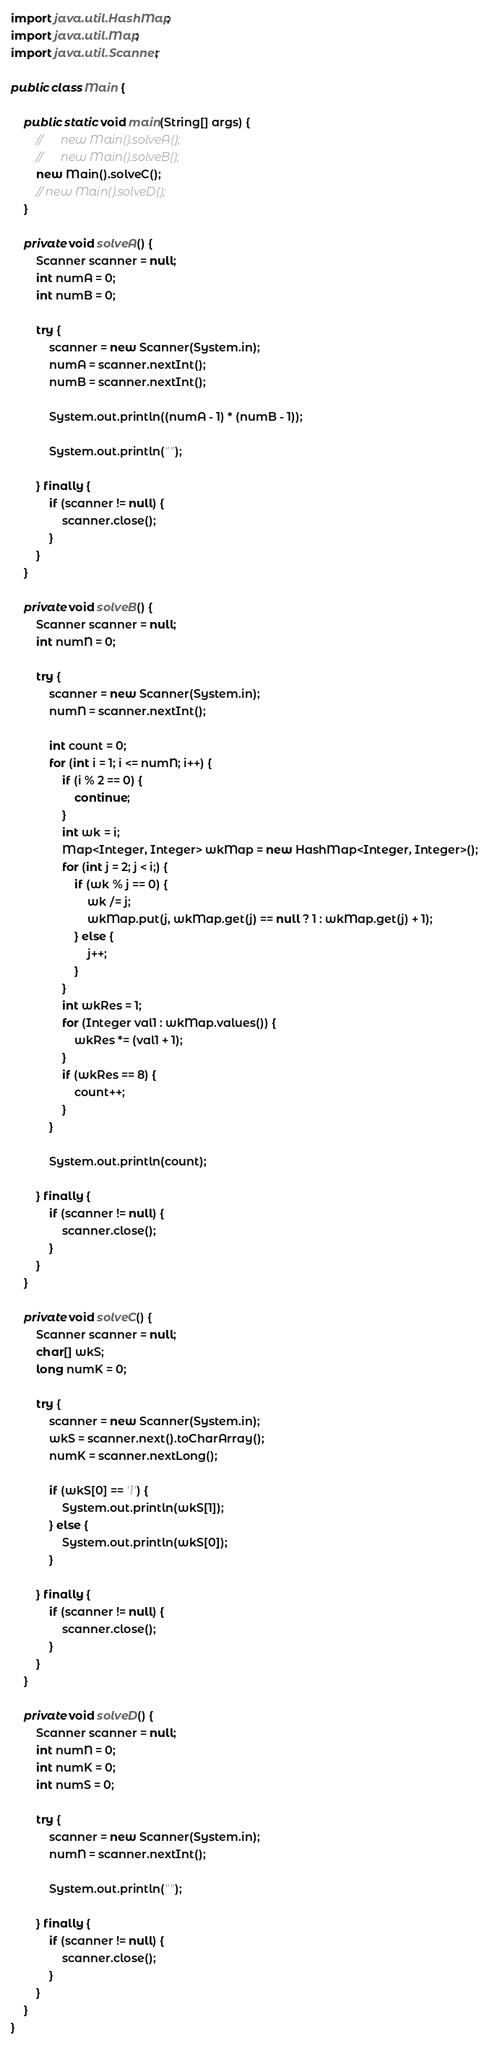Convert code to text. <code><loc_0><loc_0><loc_500><loc_500><_Java_>
import java.util.HashMap;
import java.util.Map;
import java.util.Scanner;

public class Main {

	public static void main(String[] args) {
		//		new Main().solveA();
		//		new Main().solveB();
		new Main().solveC();
		// new Main().solveD();
	}

	private void solveA() {
		Scanner scanner = null;
		int numA = 0;
		int numB = 0;

		try {
			scanner = new Scanner(System.in);
			numA = scanner.nextInt();
			numB = scanner.nextInt();

			System.out.println((numA - 1) * (numB - 1));

			System.out.println("");

		} finally {
			if (scanner != null) {
				scanner.close();
			}
		}
	}

	private void solveB() {
		Scanner scanner = null;
		int numN = 0;

		try {
			scanner = new Scanner(System.in);
			numN = scanner.nextInt();

			int count = 0;
			for (int i = 1; i <= numN; i++) {
				if (i % 2 == 0) {
					continue;
				}
				int wk = i;
				Map<Integer, Integer> wkMap = new HashMap<Integer, Integer>();
				for (int j = 2; j < i;) {
					if (wk % j == 0) {
						wk /= j;
						wkMap.put(j, wkMap.get(j) == null ? 1 : wkMap.get(j) + 1);
					} else {
						j++;
					}
				}
				int wkRes = 1;
				for (Integer val1 : wkMap.values()) {
					wkRes *= (val1 + 1);
				}
				if (wkRes == 8) {
					count++;
				}
			}

			System.out.println(count);

		} finally {
			if (scanner != null) {
				scanner.close();
			}
		}
	}

	private void solveC() {
		Scanner scanner = null;
		char[] wkS;
		long numK = 0;

		try {
			scanner = new Scanner(System.in);
			wkS = scanner.next().toCharArray();
			numK = scanner.nextLong();

			if (wkS[0] == '1') {
				System.out.println(wkS[1]);
			} else {
				System.out.println(wkS[0]);
			}

		} finally {
			if (scanner != null) {
				scanner.close();
			}
		}
	}

	private void solveD() {
		Scanner scanner = null;
		int numN = 0;
		int numK = 0;
		int numS = 0;

		try {
			scanner = new Scanner(System.in);
			numN = scanner.nextInt();

			System.out.println("");

		} finally {
			if (scanner != null) {
				scanner.close();
			}
		}
	}
}</code> 